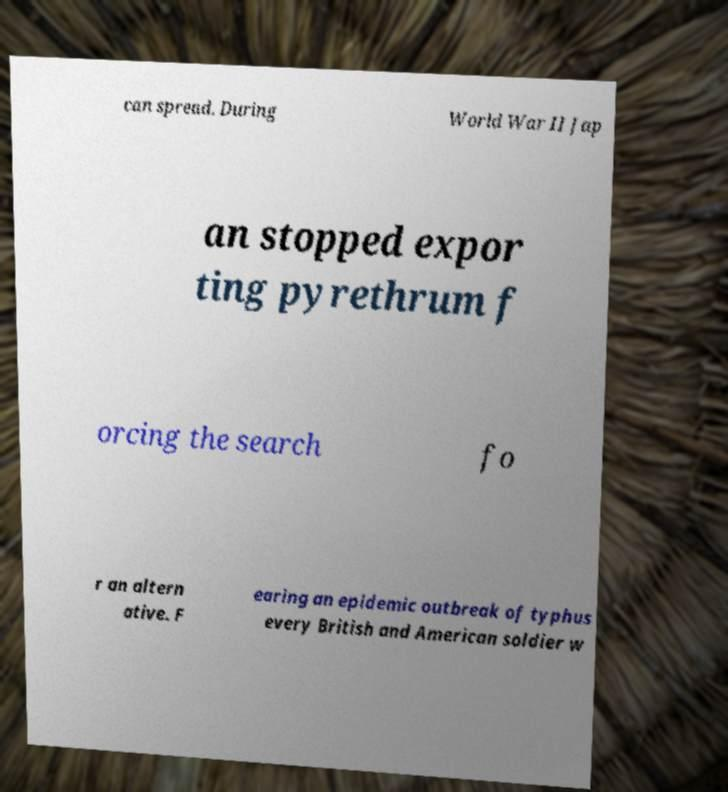Please identify and transcribe the text found in this image. can spread. During World War II Jap an stopped expor ting pyrethrum f orcing the search fo r an altern ative. F earing an epidemic outbreak of typhus every British and American soldier w 